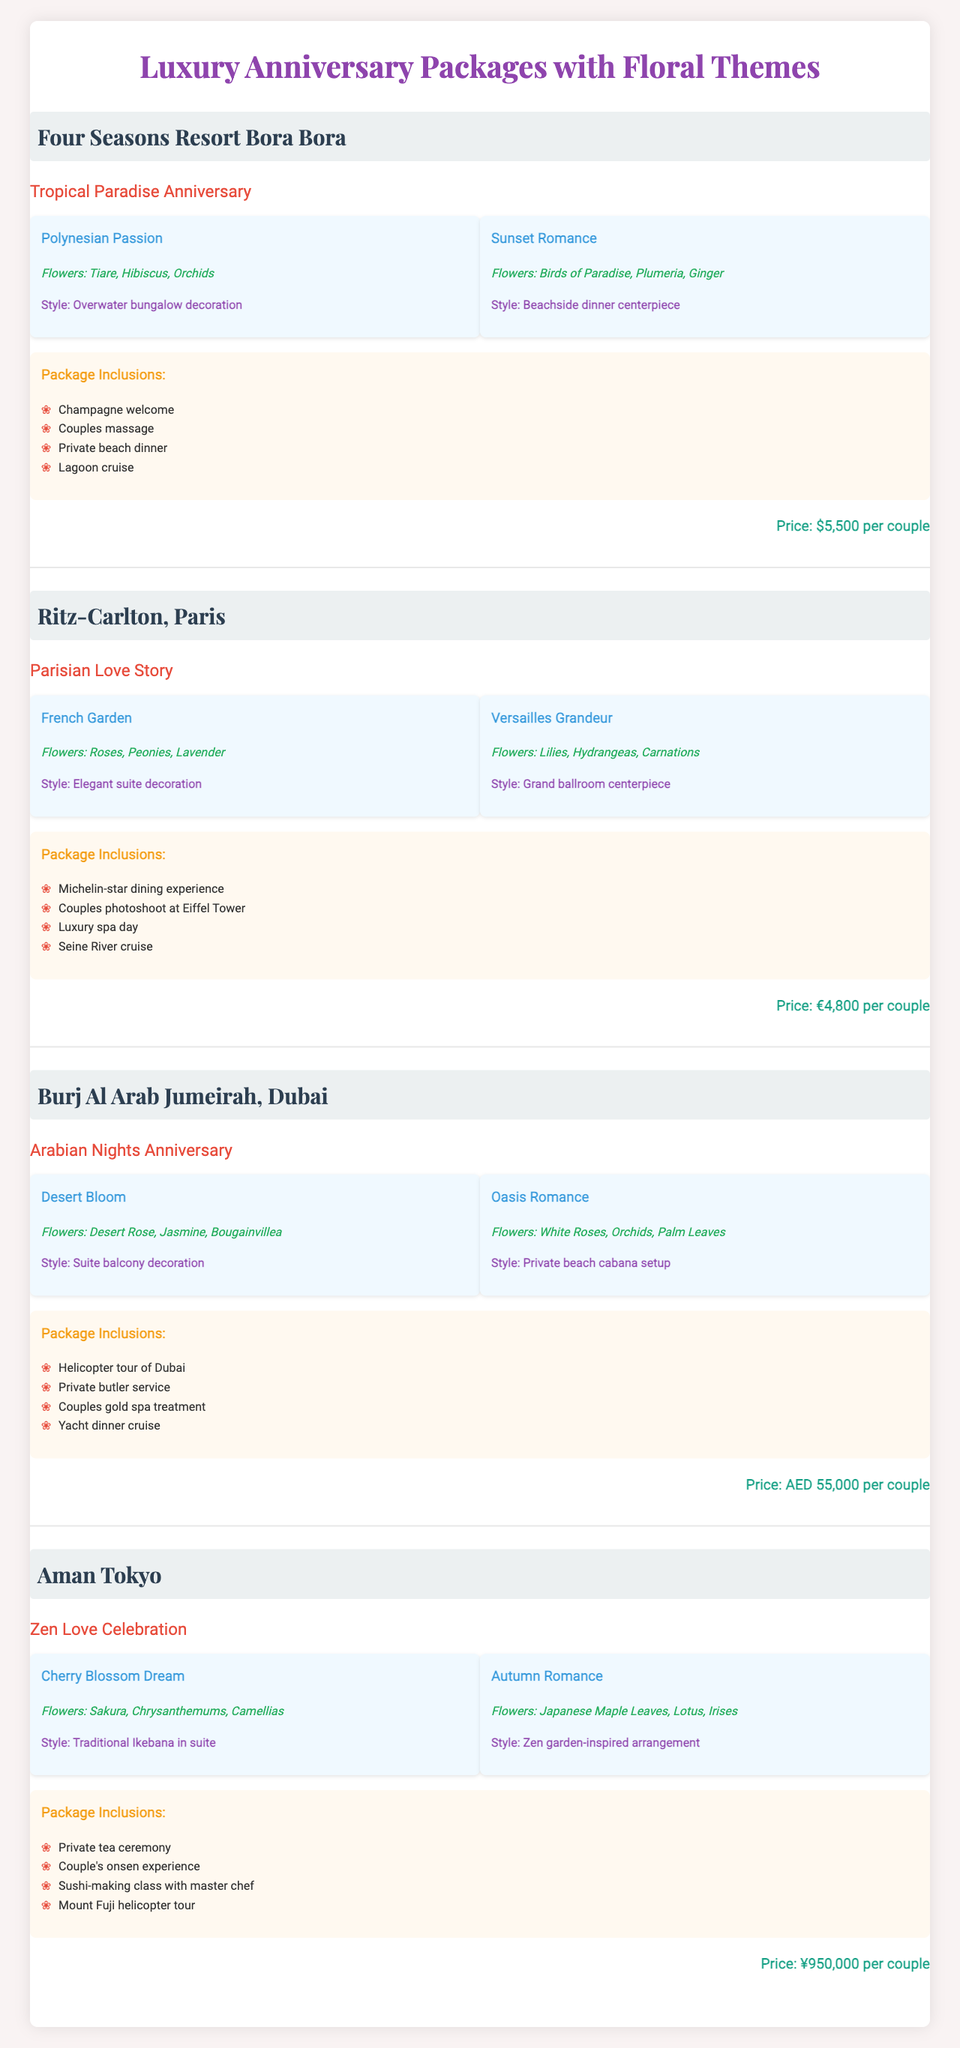What is the price of the "Tropical Paradise Anniversary" package? The price of the "Tropical Paradise Anniversary" package from Four Seasons Resort Bora Bora is listed as $5,500 per couple.
Answer: $5,500 Which hotel offers the "Zen Love Celebration" package? The "Zen Love Celebration" package is offered by Aman Tokyo, as indicated in the table.
Answer: Aman Tokyo How many different floral themes are included in the "Arabian Nights Anniversary" package? The "Arabian Nights Anniversary" package has two floral themes: "Desert Bloom" and "Oasis Romance."
Answer: 2 Is a couples photoshoot included in the "Parisian Love Story" package? Yes, the package includes a couples photoshoot at the Eiffel Tower, as listed in the package inclusions.
Answer: Yes Which hotel has the highest price for its anniversary package? To determine the highest price, we compare the prices: Four Seasons Resort Bora Bora ($5,500), Ritz-Carlton Paris (€4,800), Burj Al Arab Jumeirah (AED 55,000), and Aman Tokyo (¥950,000). AED 55,000 is the highest, but we need to convert it for accurate comparison. After conversion to a common currency, Burj Al Arab's package is the most expensive.
Answer: Burj Al Arab Jumeirah What flower types are included in the "French Garden" theme? The "French Garden" theme includes Rose, Peonies, and Lavender, as listed under the floral themes for the Ritz-Carlton, Paris.
Answer: Roses, Peonies, Lavender Which arrangement style is used for the "Sunset Romance" theme? The arrangement style for the "Sunset Romance" theme is "Beachside dinner centerpiece," indicated in the table under the floral themes for Four Seasons Resort Bora Bora.
Answer: Beachside dinner centerpiece What is the combined total price of the "Tropical Paradise Anniversary" and "Zen Love Celebration" packages in a common currency? The "Tropical Paradise Anniversary" costs $5,500, and the "Zen Love Celebration" costs ¥950,000. For accurate comparison, we convert $5,500 to yen. Assuming the exchange rate is $1 = ¥150, that makes it ¥825,000. Adding ¥825,000 and ¥950,000 gives ¥1,775,000.
Answer: ¥1,775,000 Do any of the packages offer a yacht dinner cruise? Yes, both the "Arabian Nights Anniversary" and "Tropical Paradise Anniversary" packages include a yacht dinner cruise among their package inclusions.
Answer: Yes Which floral theme uses "Sakura" as one of its flower types? The "Cherry Blossom Dream" theme includes "Sakura" as listed under the Aman Tokyo's floral themes.
Answer: Cherry Blossom Dream What is the total number of package inclusions for the Ritz-Carlton, Paris? The Ritz-Carlton, Paris has four package inclusions: Michelin-star dining experience, couples photoshoot at the Eiffel Tower, luxury spa day, and Seine River cruise. Count them gives us a total of 4.
Answer: 4 